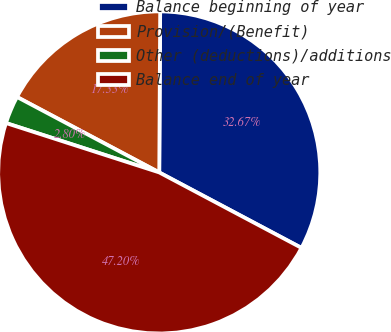Convert chart to OTSL. <chart><loc_0><loc_0><loc_500><loc_500><pie_chart><fcel>Balance beginning of year<fcel>Provision/(Benefit)<fcel>Other (deductions)/additions<fcel>Balance end of year<nl><fcel>32.67%<fcel>17.33%<fcel>2.8%<fcel>47.2%<nl></chart> 